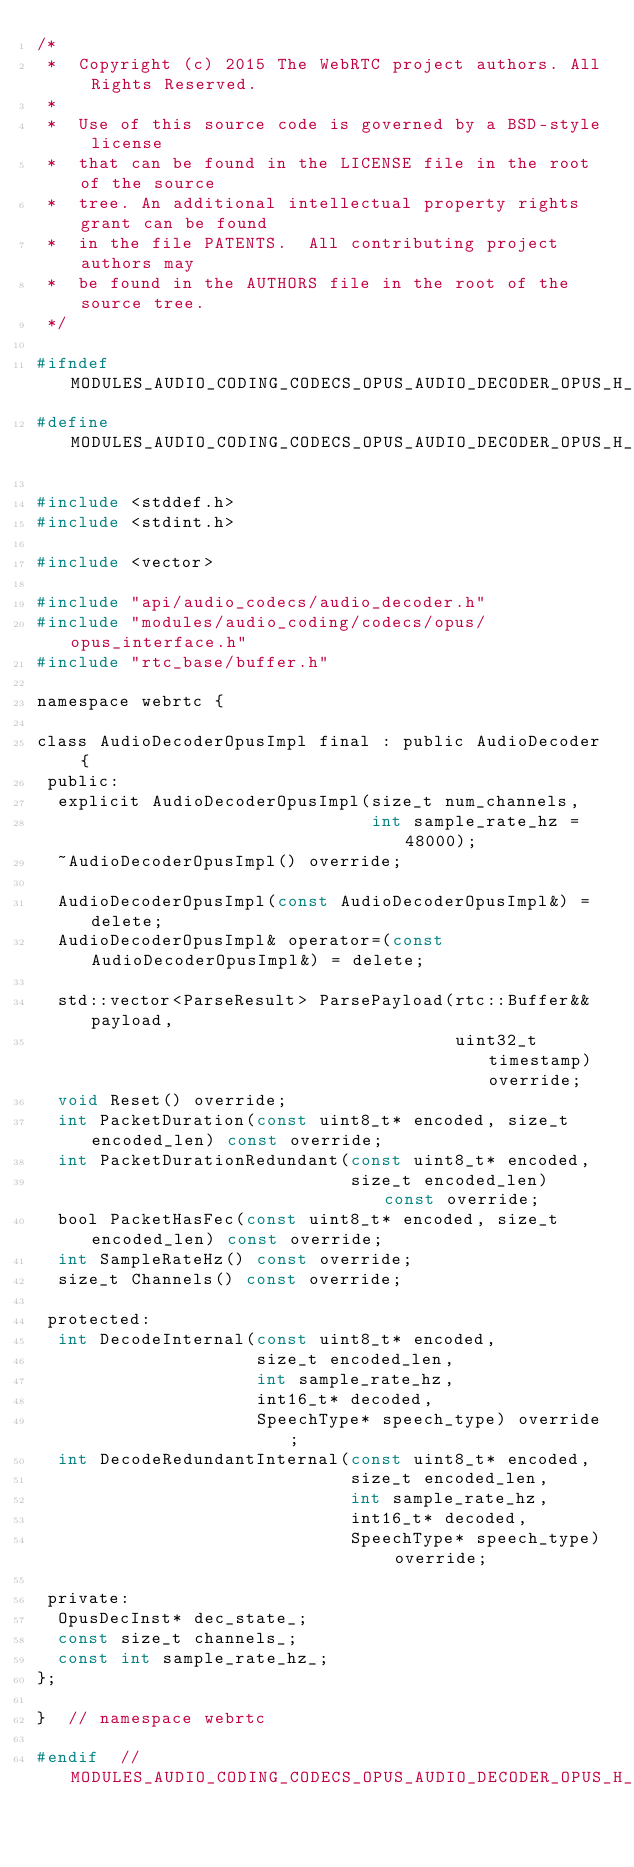<code> <loc_0><loc_0><loc_500><loc_500><_C_>/*
 *  Copyright (c) 2015 The WebRTC project authors. All Rights Reserved.
 *
 *  Use of this source code is governed by a BSD-style license
 *  that can be found in the LICENSE file in the root of the source
 *  tree. An additional intellectual property rights grant can be found
 *  in the file PATENTS.  All contributing project authors may
 *  be found in the AUTHORS file in the root of the source tree.
 */

#ifndef MODULES_AUDIO_CODING_CODECS_OPUS_AUDIO_DECODER_OPUS_H_
#define MODULES_AUDIO_CODING_CODECS_OPUS_AUDIO_DECODER_OPUS_H_

#include <stddef.h>
#include <stdint.h>

#include <vector>

#include "api/audio_codecs/audio_decoder.h"
#include "modules/audio_coding/codecs/opus/opus_interface.h"
#include "rtc_base/buffer.h"

namespace webrtc {

class AudioDecoderOpusImpl final : public AudioDecoder {
 public:
  explicit AudioDecoderOpusImpl(size_t num_channels,
                                int sample_rate_hz = 48000);
  ~AudioDecoderOpusImpl() override;

  AudioDecoderOpusImpl(const AudioDecoderOpusImpl&) = delete;
  AudioDecoderOpusImpl& operator=(const AudioDecoderOpusImpl&) = delete;

  std::vector<ParseResult> ParsePayload(rtc::Buffer&& payload,
                                        uint32_t timestamp) override;
  void Reset() override;
  int PacketDuration(const uint8_t* encoded, size_t encoded_len) const override;
  int PacketDurationRedundant(const uint8_t* encoded,
                              size_t encoded_len) const override;
  bool PacketHasFec(const uint8_t* encoded, size_t encoded_len) const override;
  int SampleRateHz() const override;
  size_t Channels() const override;

 protected:
  int DecodeInternal(const uint8_t* encoded,
                     size_t encoded_len,
                     int sample_rate_hz,
                     int16_t* decoded,
                     SpeechType* speech_type) override;
  int DecodeRedundantInternal(const uint8_t* encoded,
                              size_t encoded_len,
                              int sample_rate_hz,
                              int16_t* decoded,
                              SpeechType* speech_type) override;

 private:
  OpusDecInst* dec_state_;
  const size_t channels_;
  const int sample_rate_hz_;
};

}  // namespace webrtc

#endif  // MODULES_AUDIO_CODING_CODECS_OPUS_AUDIO_DECODER_OPUS_H_
</code> 